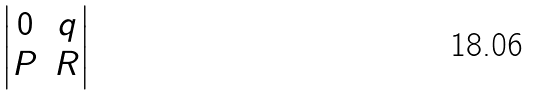<formula> <loc_0><loc_0><loc_500><loc_500>\begin{vmatrix} 0 & q \\ P & R \end{vmatrix}</formula> 